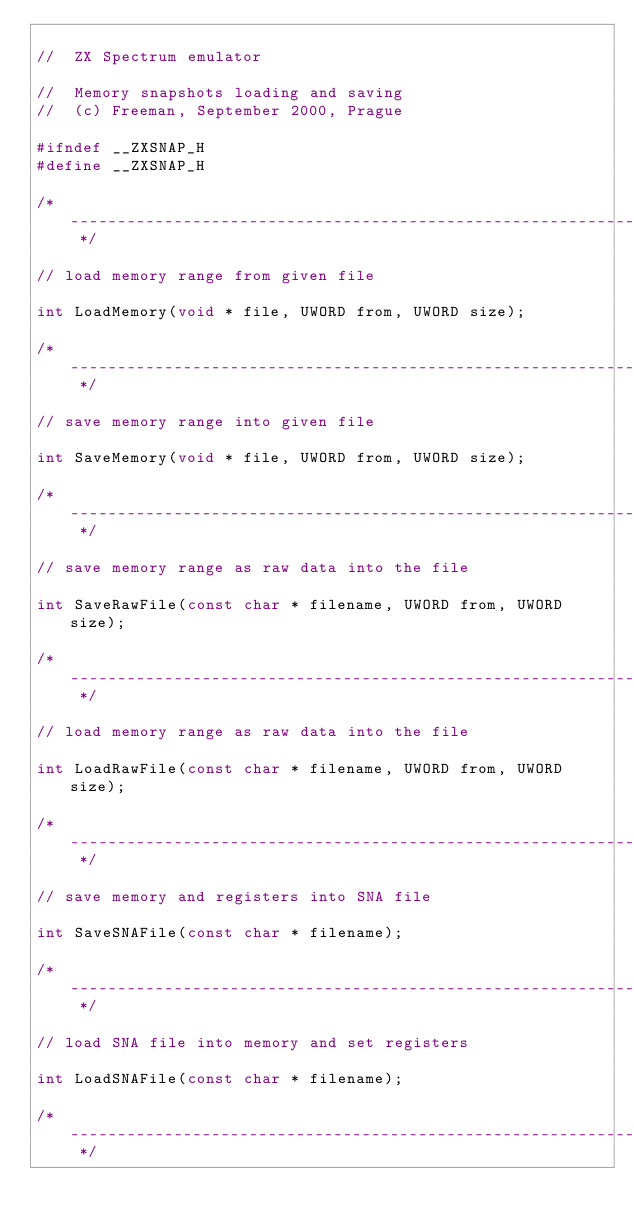Convert code to text. <code><loc_0><loc_0><loc_500><loc_500><_C_>
//	ZX Spectrum emulator

//	Memory snapshots loading and saving
//	(c) Freeman, September 2000, Prague

#ifndef	__ZXSNAP_H
#define	__ZXSNAP_H

/* ------------------------------------------------------------------------- */

// load memory range from given file

int LoadMemory(void * file, UWORD from, UWORD size);

/* ------------------------------------------------------------------------- */

// save memory range into given file

int SaveMemory(void * file, UWORD from, UWORD size);

/* ------------------------------------------------------------------------- */

// save memory range as raw data into the file

int SaveRawFile(const char * filename, UWORD from, UWORD size);

/* ------------------------------------------------------------------------- */

// load memory range as raw data into the file

int LoadRawFile(const char * filename, UWORD from, UWORD size);

/* ------------------------------------------------------------------------- */

// save memory and registers into SNA file 

int SaveSNAFile(const char * filename);

/* ------------------------------------------------------------------------- */

// load SNA file into memory and set registers

int LoadSNAFile(const char * filename);

/* ------------------------------------------------------------------------- */
</code> 